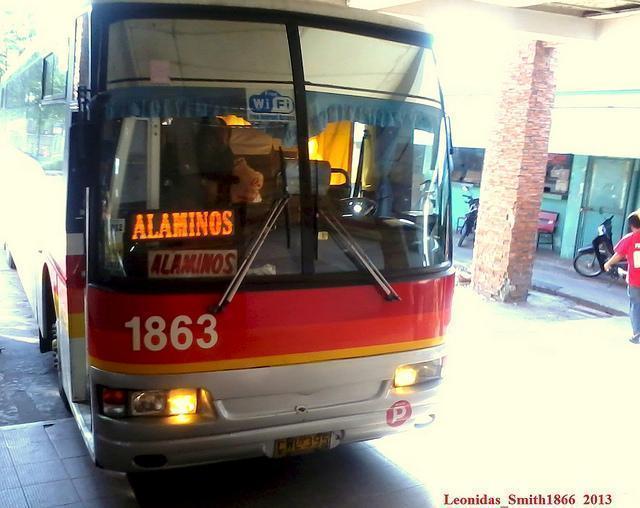What are the metal poles on the window called?
From the following set of four choices, select the accurate answer to respond to the question.
Options: Shuttle sticks, handles, rackets, wipes. Wipes. 